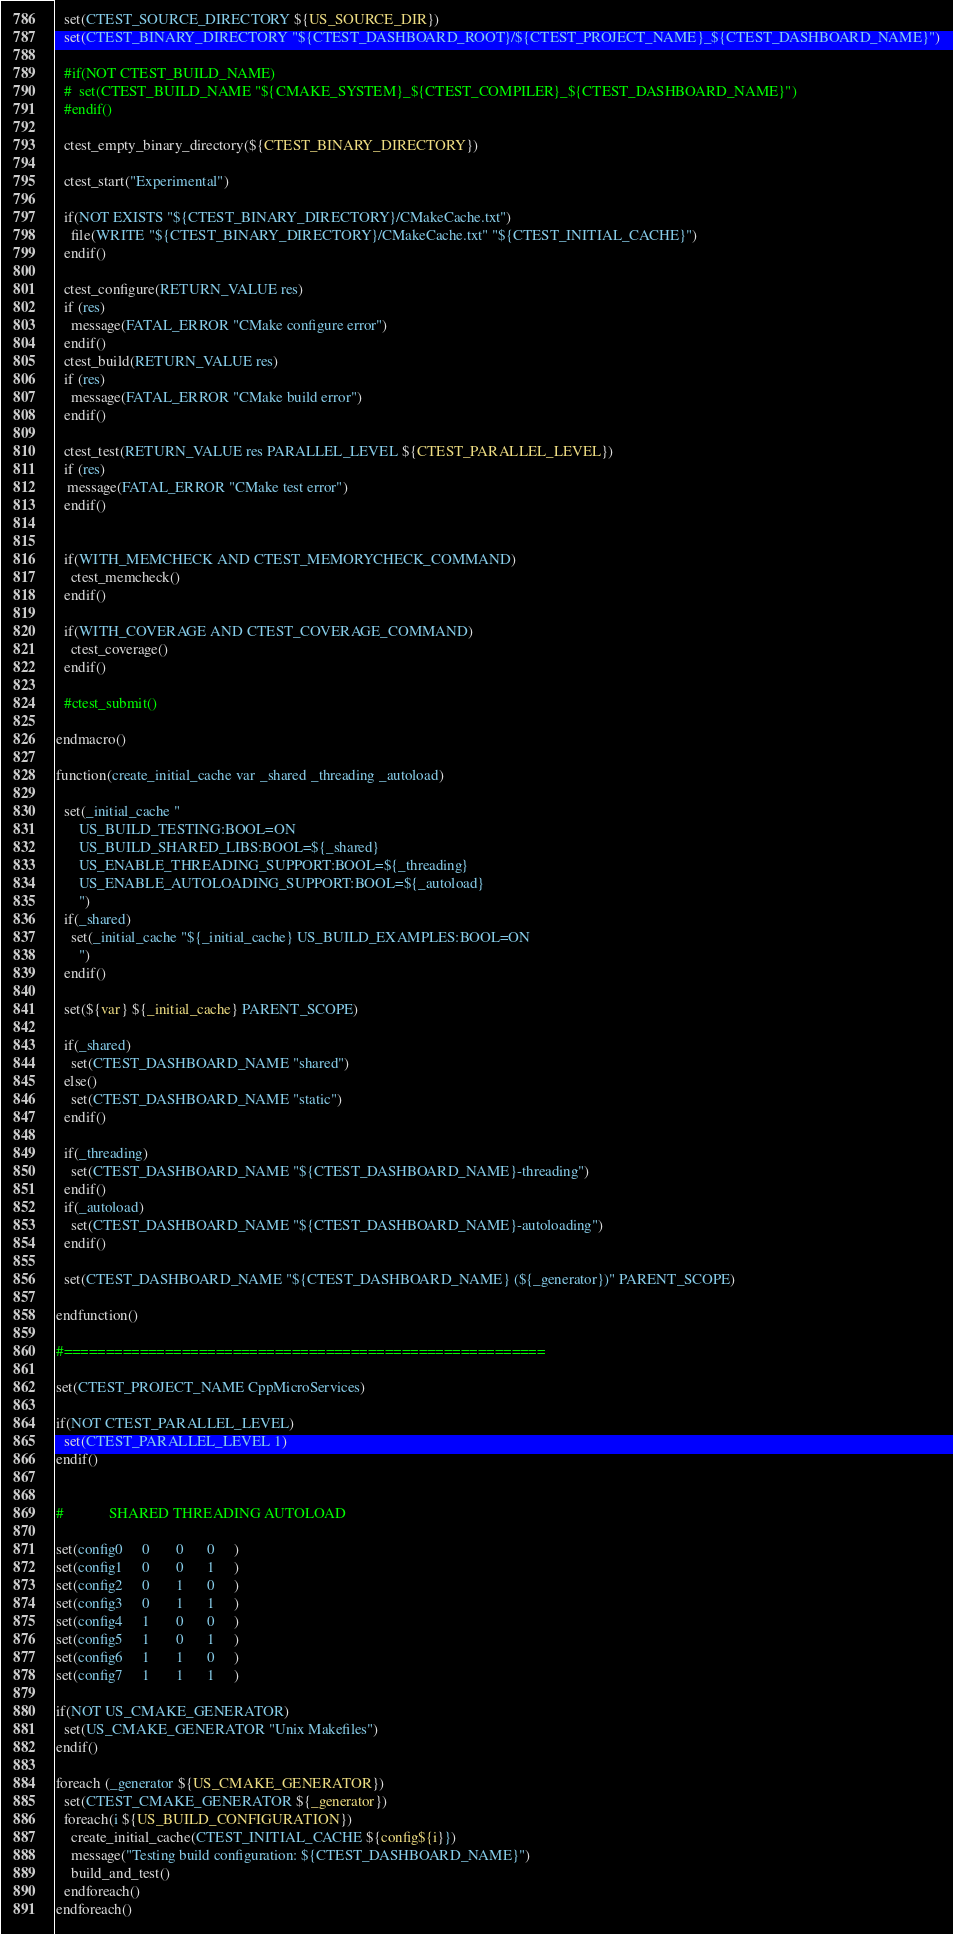<code> <loc_0><loc_0><loc_500><loc_500><_CMake_>
  set(CTEST_SOURCE_DIRECTORY ${US_SOURCE_DIR})
  set(CTEST_BINARY_DIRECTORY "${CTEST_DASHBOARD_ROOT}/${CTEST_PROJECT_NAME}_${CTEST_DASHBOARD_NAME}")

  #if(NOT CTEST_BUILD_NAME)
  #  set(CTEST_BUILD_NAME "${CMAKE_SYSTEM}_${CTEST_COMPILER}_${CTEST_DASHBOARD_NAME}")
  #endif()

  ctest_empty_binary_directory(${CTEST_BINARY_DIRECTORY})

  ctest_start("Experimental")

  if(NOT EXISTS "${CTEST_BINARY_DIRECTORY}/CMakeCache.txt")
    file(WRITE "${CTEST_BINARY_DIRECTORY}/CMakeCache.txt" "${CTEST_INITIAL_CACHE}")
  endif()

  ctest_configure(RETURN_VALUE res)
  if (res)
    message(FATAL_ERROR "CMake configure error")
  endif()
  ctest_build(RETURN_VALUE res)
  if (res)
    message(FATAL_ERROR "CMake build error")
  endif()

  ctest_test(RETURN_VALUE res PARALLEL_LEVEL ${CTEST_PARALLEL_LEVEL})
  if (res)
   message(FATAL_ERROR "CMake test error")
  endif()


  if(WITH_MEMCHECK AND CTEST_MEMORYCHECK_COMMAND)
    ctest_memcheck()
  endif()

  if(WITH_COVERAGE AND CTEST_COVERAGE_COMMAND)
    ctest_coverage()
  endif()

  #ctest_submit()

endmacro()

function(create_initial_cache var _shared _threading _autoload)

  set(_initial_cache "
      US_BUILD_TESTING:BOOL=ON
      US_BUILD_SHARED_LIBS:BOOL=${_shared}
      US_ENABLE_THREADING_SUPPORT:BOOL=${_threading}
      US_ENABLE_AUTOLOADING_SUPPORT:BOOL=${_autoload}
      ")
  if(_shared)
    set(_initial_cache "${_initial_cache} US_BUILD_EXAMPLES:BOOL=ON
      ")
  endif()

  set(${var} ${_initial_cache} PARENT_SCOPE)

  if(_shared)
    set(CTEST_DASHBOARD_NAME "shared")
  else()
    set(CTEST_DASHBOARD_NAME "static")
  endif()

  if(_threading)
    set(CTEST_DASHBOARD_NAME "${CTEST_DASHBOARD_NAME}-threading")
  endif()
  if(_autoload)
    set(CTEST_DASHBOARD_NAME "${CTEST_DASHBOARD_NAME}-autoloading")
  endif()

  set(CTEST_DASHBOARD_NAME "${CTEST_DASHBOARD_NAME} (${_generator})" PARENT_SCOPE)

endfunction()

#=========================================================

set(CTEST_PROJECT_NAME CppMicroServices)

if(NOT CTEST_PARALLEL_LEVEL)
  set(CTEST_PARALLEL_LEVEL 1)
endif()


#            SHARED THREADING AUTOLOAD

set(config0     0       0      0     )
set(config1     0       0      1     )
set(config2     0       1      0     )
set(config3     0       1      1     )
set(config4     1       0      0     )
set(config5     1       0      1     )
set(config6     1       1      0     )
set(config7     1       1      1     )

if(NOT US_CMAKE_GENERATOR)
  set(US_CMAKE_GENERATOR "Unix Makefiles")
endif()

foreach (_generator ${US_CMAKE_GENERATOR})
  set(CTEST_CMAKE_GENERATOR ${_generator})
  foreach(i ${US_BUILD_CONFIGURATION})
    create_initial_cache(CTEST_INITIAL_CACHE ${config${i}})
    message("Testing build configuration: ${CTEST_DASHBOARD_NAME}")
    build_and_test()
  endforeach()
endforeach()
</code> 